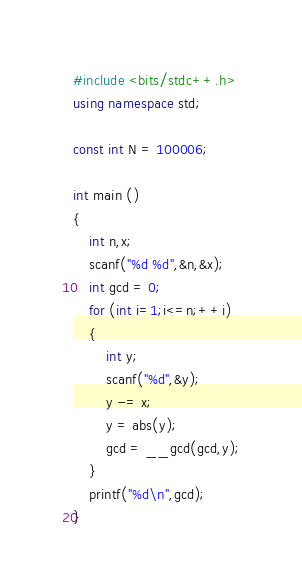Convert code to text. <code><loc_0><loc_0><loc_500><loc_500><_C++_>#include <bits/stdc++.h>
using namespace std;

const int N = 100006;

int main ()
{
    int n,x;
    scanf("%d %d",&n,&x);
    int gcd = 0;
    for (int i=1;i<=n;++i)
    {
        int y;
        scanf("%d",&y);
        y -= x;
        y = abs(y);
        gcd = __gcd(gcd,y);
    }
    printf("%d\n",gcd);
}

</code> 